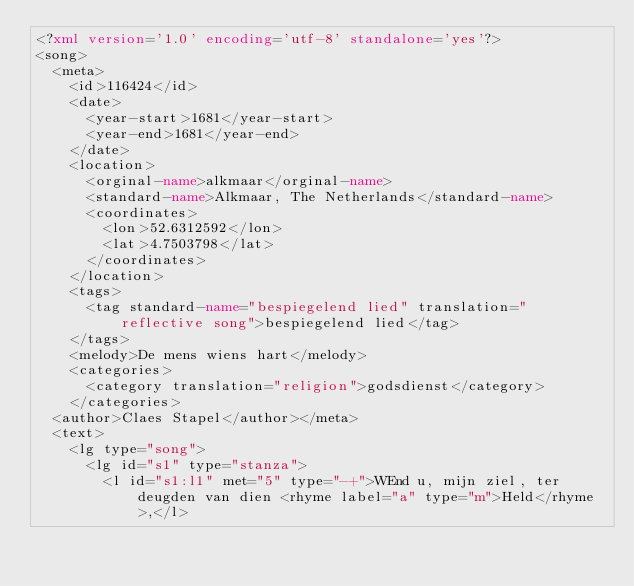Convert code to text. <code><loc_0><loc_0><loc_500><loc_500><_XML_><?xml version='1.0' encoding='utf-8' standalone='yes'?>
<song>
  <meta>
    <id>116424</id>
    <date>
      <year-start>1681</year-start>
      <year-end>1681</year-end>
    </date>
    <location>
      <orginal-name>alkmaar</orginal-name>
      <standard-name>Alkmaar, The Netherlands</standard-name>
      <coordinates>
        <lon>52.6312592</lon>
        <lat>4.7503798</lat>
      </coordinates>
    </location>
    <tags>
      <tag standard-name="bespiegelend lied" translation="reflective song">bespiegelend lied</tag>
    </tags>
    <melody>De mens wiens hart</melody>
    <categories>
      <category translation="religion">godsdienst</category>
    </categories>
  <author>Claes Stapel</author></meta>
  <text>
    <lg type="song">
      <lg id="s1" type="stanza">
        <l id="s1:l1" met="5" type="-+">WEnd u, mijn ziel, ter deugden van dien <rhyme label="a" type="m">Held</rhyme>,</l></code> 